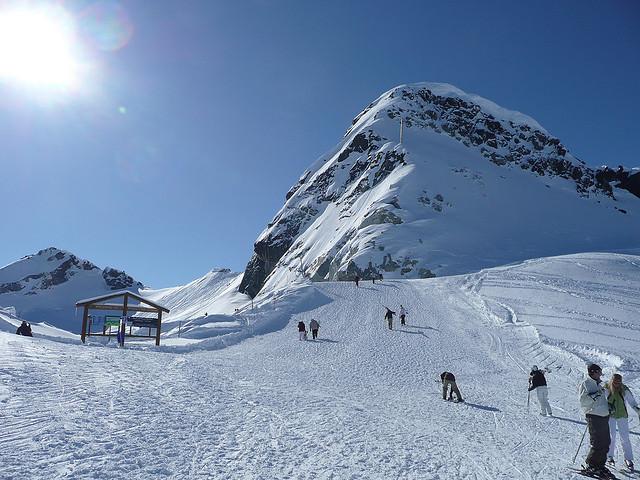Are there people on the snowing hill?
Short answer required. Yes. Is there snow?
Short answer required. Yes. Is it sunny or cloudy?
Quick response, please. Sunny. Is there a red coat in this picture?
Quick response, please. No. 